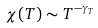Convert formula to latex. <formula><loc_0><loc_0><loc_500><loc_500>\chi ( T ) \sim T ^ { - \gamma _ { T } }</formula> 